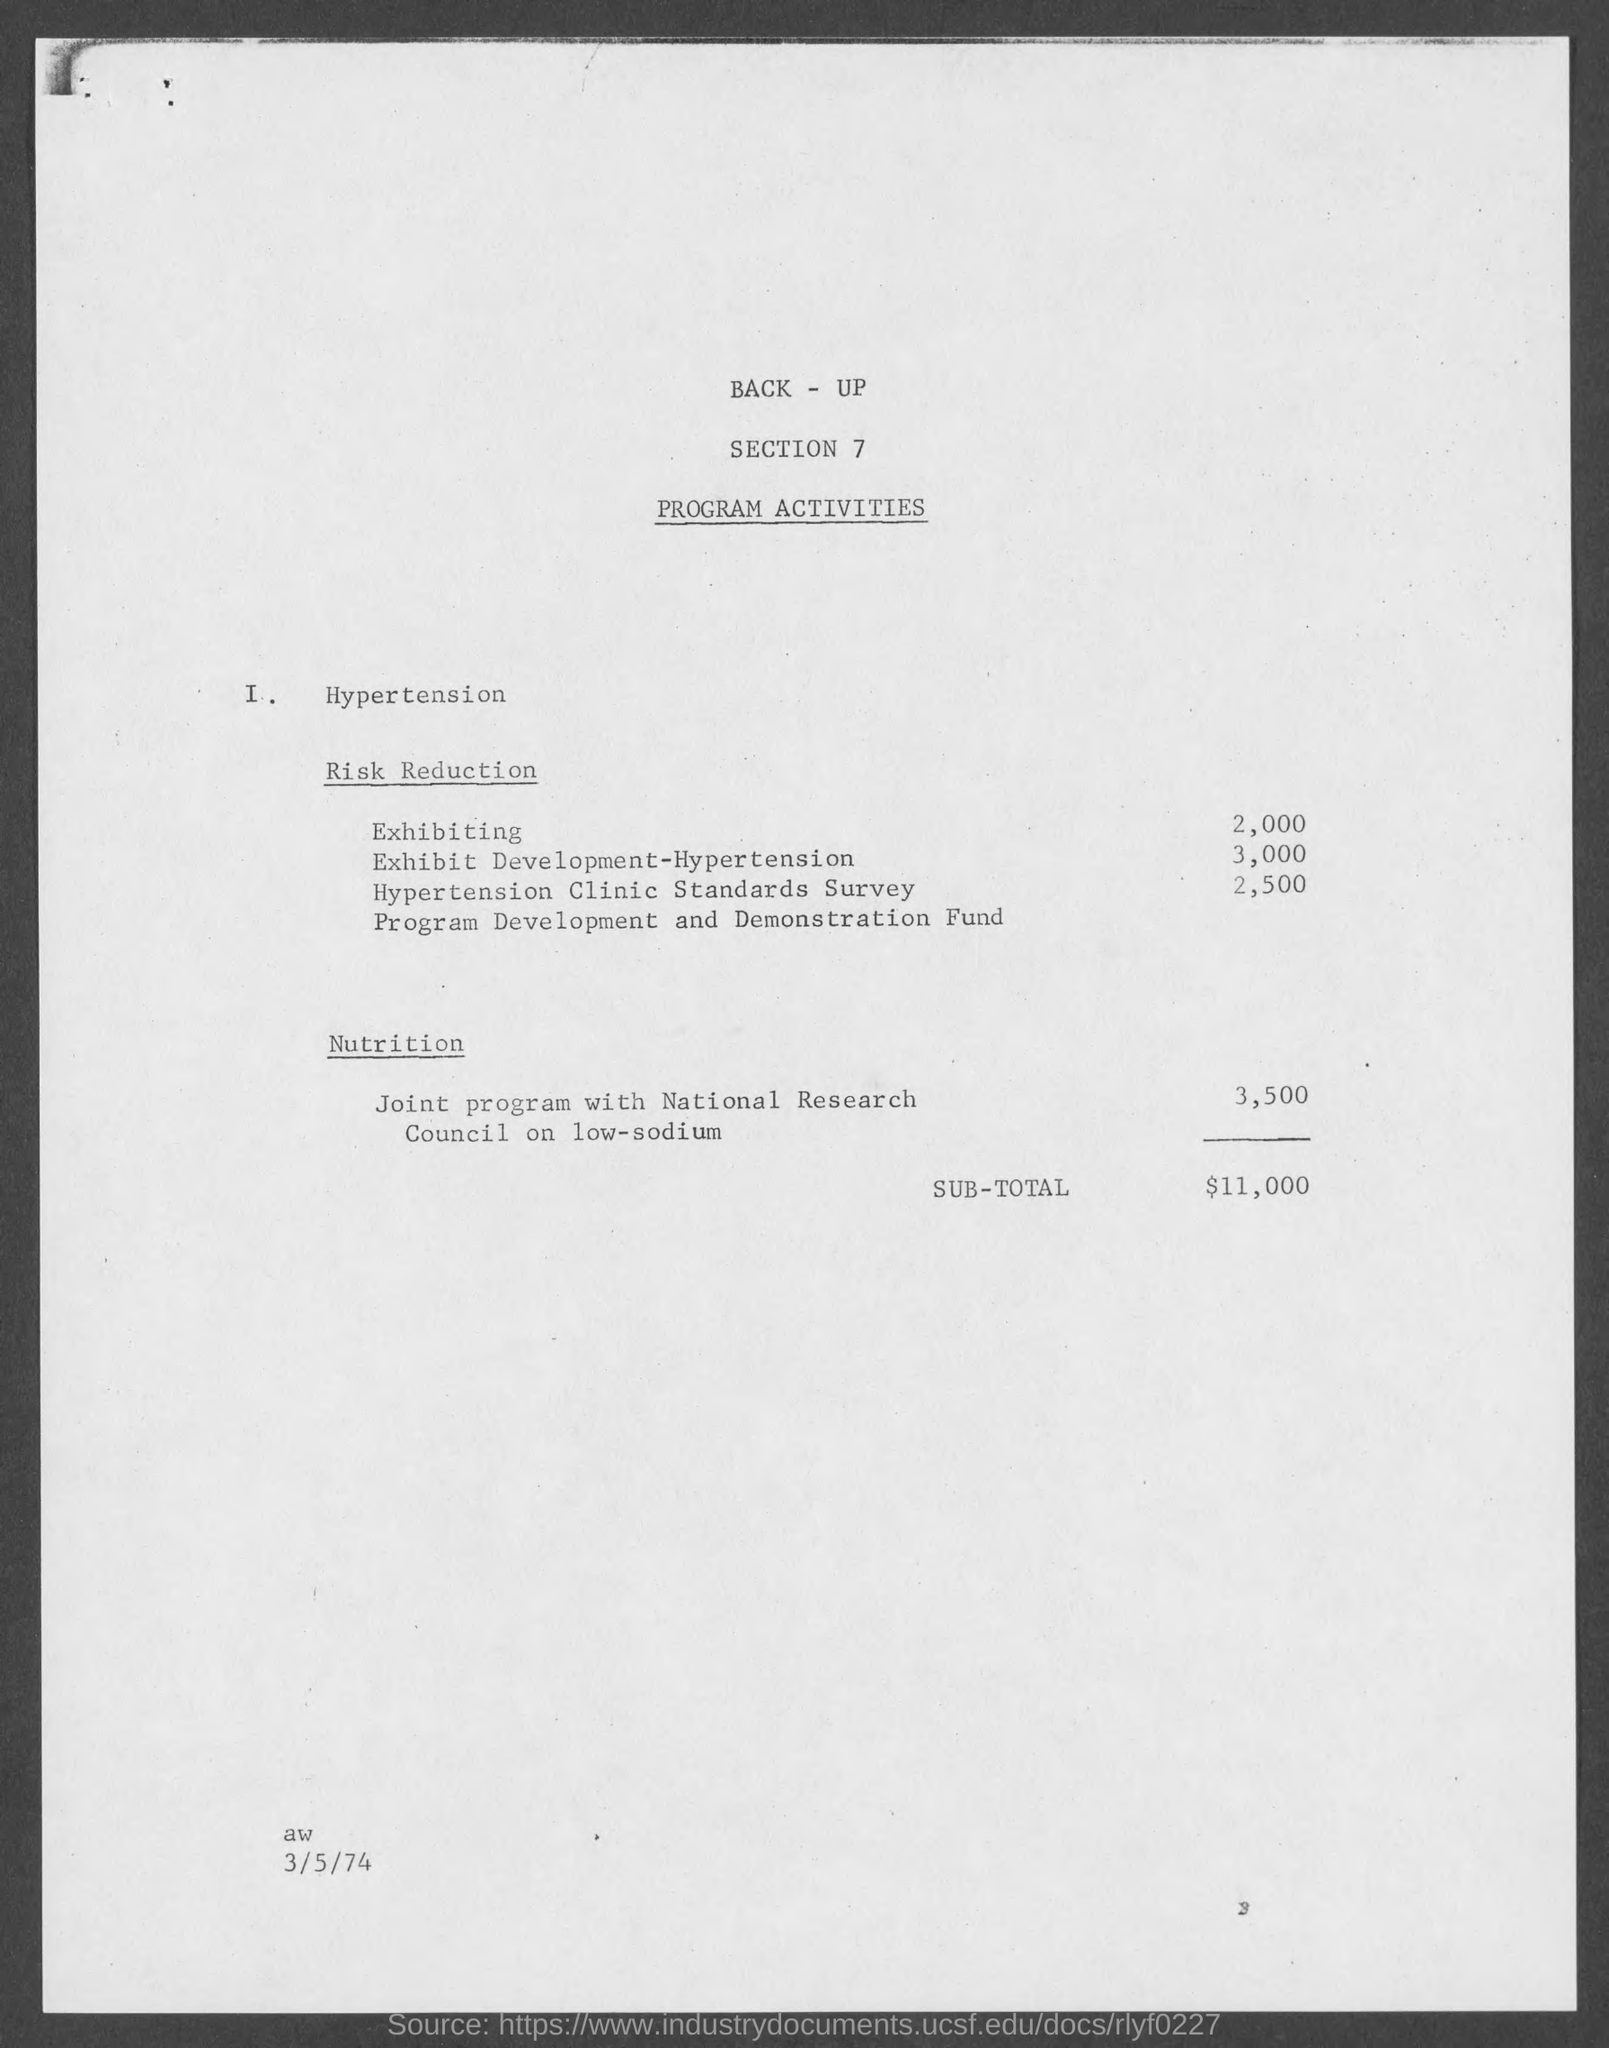Highlight a few significant elements in this photo. The cost of exhibiting is 2,000. The cost of Exhibit Development-Hypertension is 3,000. The sub-total is $11,000. 